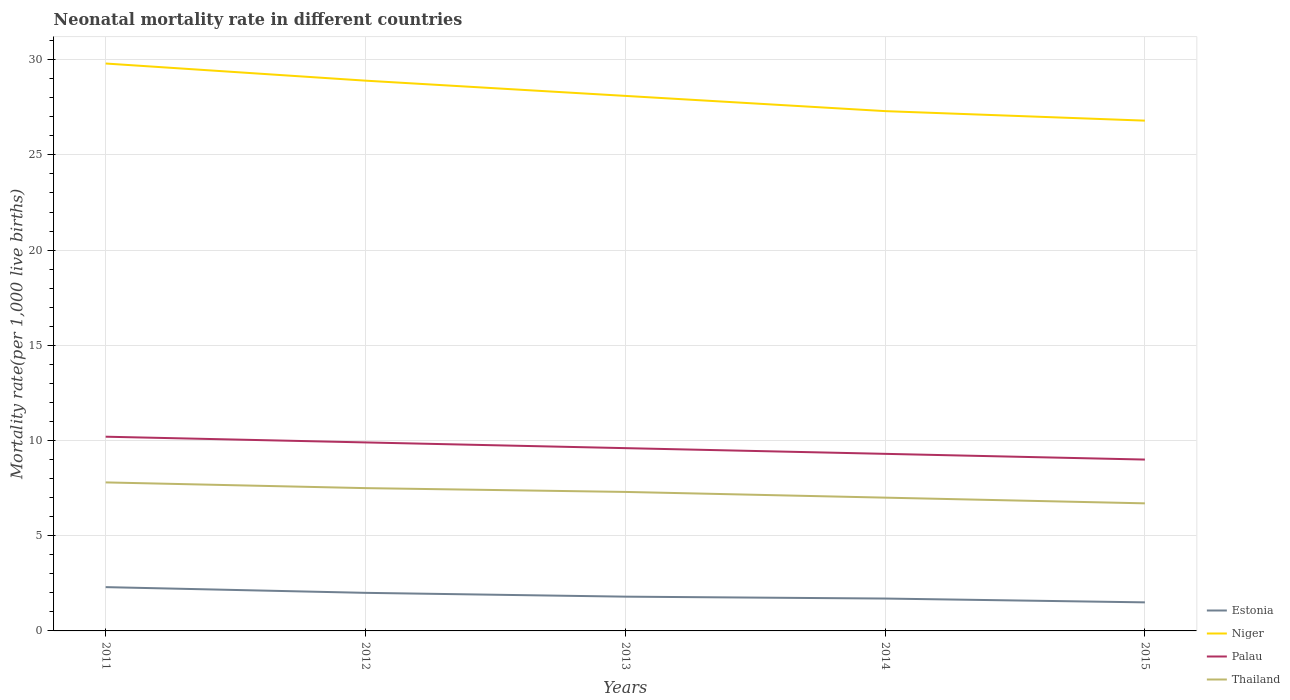How many different coloured lines are there?
Your answer should be compact. 4. Does the line corresponding to Palau intersect with the line corresponding to Niger?
Ensure brevity in your answer.  No. Across all years, what is the maximum neonatal mortality rate in Estonia?
Give a very brief answer. 1.5. In which year was the neonatal mortality rate in Niger maximum?
Offer a very short reply. 2015. What is the total neonatal mortality rate in Thailand in the graph?
Provide a short and direct response. 0.3. What is the difference between the highest and the second highest neonatal mortality rate in Estonia?
Make the answer very short. 0.8. How many years are there in the graph?
Give a very brief answer. 5. Are the values on the major ticks of Y-axis written in scientific E-notation?
Your answer should be compact. No. Does the graph contain any zero values?
Make the answer very short. No. Where does the legend appear in the graph?
Offer a very short reply. Bottom right. How are the legend labels stacked?
Your answer should be compact. Vertical. What is the title of the graph?
Offer a terse response. Neonatal mortality rate in different countries. What is the label or title of the X-axis?
Make the answer very short. Years. What is the label or title of the Y-axis?
Make the answer very short. Mortality rate(per 1,0 live births). What is the Mortality rate(per 1,000 live births) of Estonia in 2011?
Your response must be concise. 2.3. What is the Mortality rate(per 1,000 live births) in Niger in 2011?
Give a very brief answer. 29.8. What is the Mortality rate(per 1,000 live births) of Estonia in 2012?
Keep it short and to the point. 2. What is the Mortality rate(per 1,000 live births) in Niger in 2012?
Provide a short and direct response. 28.9. What is the Mortality rate(per 1,000 live births) of Palau in 2012?
Provide a succinct answer. 9.9. What is the Mortality rate(per 1,000 live births) of Estonia in 2013?
Make the answer very short. 1.8. What is the Mortality rate(per 1,000 live births) of Niger in 2013?
Give a very brief answer. 28.1. What is the Mortality rate(per 1,000 live births) in Palau in 2013?
Offer a very short reply. 9.6. What is the Mortality rate(per 1,000 live births) of Thailand in 2013?
Make the answer very short. 7.3. What is the Mortality rate(per 1,000 live births) of Estonia in 2014?
Offer a very short reply. 1.7. What is the Mortality rate(per 1,000 live births) in Niger in 2014?
Your response must be concise. 27.3. What is the Mortality rate(per 1,000 live births) in Palau in 2014?
Keep it short and to the point. 9.3. What is the Mortality rate(per 1,000 live births) of Thailand in 2014?
Your answer should be very brief. 7. What is the Mortality rate(per 1,000 live births) in Estonia in 2015?
Your answer should be compact. 1.5. What is the Mortality rate(per 1,000 live births) in Niger in 2015?
Provide a short and direct response. 26.8. What is the Mortality rate(per 1,000 live births) in Thailand in 2015?
Keep it short and to the point. 6.7. Across all years, what is the maximum Mortality rate(per 1,000 live births) of Estonia?
Your answer should be compact. 2.3. Across all years, what is the maximum Mortality rate(per 1,000 live births) of Niger?
Your response must be concise. 29.8. Across all years, what is the maximum Mortality rate(per 1,000 live births) in Palau?
Offer a very short reply. 10.2. Across all years, what is the minimum Mortality rate(per 1,000 live births) of Estonia?
Offer a terse response. 1.5. Across all years, what is the minimum Mortality rate(per 1,000 live births) in Niger?
Your answer should be very brief. 26.8. Across all years, what is the minimum Mortality rate(per 1,000 live births) in Palau?
Keep it short and to the point. 9. Across all years, what is the minimum Mortality rate(per 1,000 live births) of Thailand?
Give a very brief answer. 6.7. What is the total Mortality rate(per 1,000 live births) of Estonia in the graph?
Offer a very short reply. 9.3. What is the total Mortality rate(per 1,000 live births) in Niger in the graph?
Give a very brief answer. 140.9. What is the total Mortality rate(per 1,000 live births) in Palau in the graph?
Provide a short and direct response. 48. What is the total Mortality rate(per 1,000 live births) of Thailand in the graph?
Offer a very short reply. 36.3. What is the difference between the Mortality rate(per 1,000 live births) in Palau in 2011 and that in 2012?
Your answer should be very brief. 0.3. What is the difference between the Mortality rate(per 1,000 live births) in Thailand in 2011 and that in 2012?
Your answer should be compact. 0.3. What is the difference between the Mortality rate(per 1,000 live births) of Estonia in 2011 and that in 2013?
Your response must be concise. 0.5. What is the difference between the Mortality rate(per 1,000 live births) of Niger in 2011 and that in 2013?
Offer a very short reply. 1.7. What is the difference between the Mortality rate(per 1,000 live births) in Niger in 2011 and that in 2014?
Make the answer very short. 2.5. What is the difference between the Mortality rate(per 1,000 live births) in Niger in 2011 and that in 2015?
Offer a terse response. 3. What is the difference between the Mortality rate(per 1,000 live births) in Thailand in 2011 and that in 2015?
Make the answer very short. 1.1. What is the difference between the Mortality rate(per 1,000 live births) of Niger in 2012 and that in 2014?
Your answer should be very brief. 1.6. What is the difference between the Mortality rate(per 1,000 live births) of Palau in 2012 and that in 2014?
Give a very brief answer. 0.6. What is the difference between the Mortality rate(per 1,000 live births) in Thailand in 2012 and that in 2015?
Offer a very short reply. 0.8. What is the difference between the Mortality rate(per 1,000 live births) of Estonia in 2013 and that in 2014?
Your response must be concise. 0.1. What is the difference between the Mortality rate(per 1,000 live births) of Thailand in 2013 and that in 2014?
Keep it short and to the point. 0.3. What is the difference between the Mortality rate(per 1,000 live births) in Estonia in 2013 and that in 2015?
Make the answer very short. 0.3. What is the difference between the Mortality rate(per 1,000 live births) of Niger in 2013 and that in 2015?
Offer a terse response. 1.3. What is the difference between the Mortality rate(per 1,000 live births) of Estonia in 2014 and that in 2015?
Offer a terse response. 0.2. What is the difference between the Mortality rate(per 1,000 live births) in Niger in 2014 and that in 2015?
Offer a very short reply. 0.5. What is the difference between the Mortality rate(per 1,000 live births) of Estonia in 2011 and the Mortality rate(per 1,000 live births) of Niger in 2012?
Offer a very short reply. -26.6. What is the difference between the Mortality rate(per 1,000 live births) in Estonia in 2011 and the Mortality rate(per 1,000 live births) in Palau in 2012?
Keep it short and to the point. -7.6. What is the difference between the Mortality rate(per 1,000 live births) in Estonia in 2011 and the Mortality rate(per 1,000 live births) in Thailand in 2012?
Your answer should be very brief. -5.2. What is the difference between the Mortality rate(per 1,000 live births) of Niger in 2011 and the Mortality rate(per 1,000 live births) of Palau in 2012?
Offer a very short reply. 19.9. What is the difference between the Mortality rate(per 1,000 live births) of Niger in 2011 and the Mortality rate(per 1,000 live births) of Thailand in 2012?
Offer a terse response. 22.3. What is the difference between the Mortality rate(per 1,000 live births) of Palau in 2011 and the Mortality rate(per 1,000 live births) of Thailand in 2012?
Your answer should be very brief. 2.7. What is the difference between the Mortality rate(per 1,000 live births) of Estonia in 2011 and the Mortality rate(per 1,000 live births) of Niger in 2013?
Offer a very short reply. -25.8. What is the difference between the Mortality rate(per 1,000 live births) in Estonia in 2011 and the Mortality rate(per 1,000 live births) in Thailand in 2013?
Your answer should be very brief. -5. What is the difference between the Mortality rate(per 1,000 live births) of Niger in 2011 and the Mortality rate(per 1,000 live births) of Palau in 2013?
Give a very brief answer. 20.2. What is the difference between the Mortality rate(per 1,000 live births) of Niger in 2011 and the Mortality rate(per 1,000 live births) of Thailand in 2013?
Give a very brief answer. 22.5. What is the difference between the Mortality rate(per 1,000 live births) in Estonia in 2011 and the Mortality rate(per 1,000 live births) in Palau in 2014?
Your answer should be compact. -7. What is the difference between the Mortality rate(per 1,000 live births) of Estonia in 2011 and the Mortality rate(per 1,000 live births) of Thailand in 2014?
Provide a short and direct response. -4.7. What is the difference between the Mortality rate(per 1,000 live births) in Niger in 2011 and the Mortality rate(per 1,000 live births) in Palau in 2014?
Provide a succinct answer. 20.5. What is the difference between the Mortality rate(per 1,000 live births) in Niger in 2011 and the Mortality rate(per 1,000 live births) in Thailand in 2014?
Make the answer very short. 22.8. What is the difference between the Mortality rate(per 1,000 live births) of Estonia in 2011 and the Mortality rate(per 1,000 live births) of Niger in 2015?
Your answer should be very brief. -24.5. What is the difference between the Mortality rate(per 1,000 live births) of Niger in 2011 and the Mortality rate(per 1,000 live births) of Palau in 2015?
Keep it short and to the point. 20.8. What is the difference between the Mortality rate(per 1,000 live births) of Niger in 2011 and the Mortality rate(per 1,000 live births) of Thailand in 2015?
Your answer should be compact. 23.1. What is the difference between the Mortality rate(per 1,000 live births) of Palau in 2011 and the Mortality rate(per 1,000 live births) of Thailand in 2015?
Offer a very short reply. 3.5. What is the difference between the Mortality rate(per 1,000 live births) of Estonia in 2012 and the Mortality rate(per 1,000 live births) of Niger in 2013?
Your answer should be compact. -26.1. What is the difference between the Mortality rate(per 1,000 live births) in Estonia in 2012 and the Mortality rate(per 1,000 live births) in Palau in 2013?
Offer a terse response. -7.6. What is the difference between the Mortality rate(per 1,000 live births) in Niger in 2012 and the Mortality rate(per 1,000 live births) in Palau in 2013?
Your answer should be very brief. 19.3. What is the difference between the Mortality rate(per 1,000 live births) of Niger in 2012 and the Mortality rate(per 1,000 live births) of Thailand in 2013?
Provide a succinct answer. 21.6. What is the difference between the Mortality rate(per 1,000 live births) in Estonia in 2012 and the Mortality rate(per 1,000 live births) in Niger in 2014?
Your response must be concise. -25.3. What is the difference between the Mortality rate(per 1,000 live births) in Estonia in 2012 and the Mortality rate(per 1,000 live births) in Thailand in 2014?
Give a very brief answer. -5. What is the difference between the Mortality rate(per 1,000 live births) of Niger in 2012 and the Mortality rate(per 1,000 live births) of Palau in 2014?
Ensure brevity in your answer.  19.6. What is the difference between the Mortality rate(per 1,000 live births) of Niger in 2012 and the Mortality rate(per 1,000 live births) of Thailand in 2014?
Ensure brevity in your answer.  21.9. What is the difference between the Mortality rate(per 1,000 live births) of Estonia in 2012 and the Mortality rate(per 1,000 live births) of Niger in 2015?
Provide a short and direct response. -24.8. What is the difference between the Mortality rate(per 1,000 live births) in Estonia in 2012 and the Mortality rate(per 1,000 live births) in Thailand in 2015?
Keep it short and to the point. -4.7. What is the difference between the Mortality rate(per 1,000 live births) of Niger in 2012 and the Mortality rate(per 1,000 live births) of Palau in 2015?
Offer a very short reply. 19.9. What is the difference between the Mortality rate(per 1,000 live births) in Niger in 2012 and the Mortality rate(per 1,000 live births) in Thailand in 2015?
Provide a short and direct response. 22.2. What is the difference between the Mortality rate(per 1,000 live births) of Palau in 2012 and the Mortality rate(per 1,000 live births) of Thailand in 2015?
Provide a short and direct response. 3.2. What is the difference between the Mortality rate(per 1,000 live births) of Estonia in 2013 and the Mortality rate(per 1,000 live births) of Niger in 2014?
Provide a succinct answer. -25.5. What is the difference between the Mortality rate(per 1,000 live births) of Estonia in 2013 and the Mortality rate(per 1,000 live births) of Thailand in 2014?
Your answer should be compact. -5.2. What is the difference between the Mortality rate(per 1,000 live births) in Niger in 2013 and the Mortality rate(per 1,000 live births) in Thailand in 2014?
Your response must be concise. 21.1. What is the difference between the Mortality rate(per 1,000 live births) in Palau in 2013 and the Mortality rate(per 1,000 live births) in Thailand in 2014?
Offer a very short reply. 2.6. What is the difference between the Mortality rate(per 1,000 live births) in Estonia in 2013 and the Mortality rate(per 1,000 live births) in Niger in 2015?
Make the answer very short. -25. What is the difference between the Mortality rate(per 1,000 live births) in Estonia in 2013 and the Mortality rate(per 1,000 live births) in Thailand in 2015?
Your response must be concise. -4.9. What is the difference between the Mortality rate(per 1,000 live births) in Niger in 2013 and the Mortality rate(per 1,000 live births) in Thailand in 2015?
Provide a succinct answer. 21.4. What is the difference between the Mortality rate(per 1,000 live births) in Estonia in 2014 and the Mortality rate(per 1,000 live births) in Niger in 2015?
Your response must be concise. -25.1. What is the difference between the Mortality rate(per 1,000 live births) in Estonia in 2014 and the Mortality rate(per 1,000 live births) in Palau in 2015?
Your answer should be very brief. -7.3. What is the difference between the Mortality rate(per 1,000 live births) in Estonia in 2014 and the Mortality rate(per 1,000 live births) in Thailand in 2015?
Your response must be concise. -5. What is the difference between the Mortality rate(per 1,000 live births) in Niger in 2014 and the Mortality rate(per 1,000 live births) in Palau in 2015?
Offer a very short reply. 18.3. What is the difference between the Mortality rate(per 1,000 live births) in Niger in 2014 and the Mortality rate(per 1,000 live births) in Thailand in 2015?
Your answer should be compact. 20.6. What is the average Mortality rate(per 1,000 live births) in Estonia per year?
Your answer should be very brief. 1.86. What is the average Mortality rate(per 1,000 live births) in Niger per year?
Your response must be concise. 28.18. What is the average Mortality rate(per 1,000 live births) of Thailand per year?
Your response must be concise. 7.26. In the year 2011, what is the difference between the Mortality rate(per 1,000 live births) of Estonia and Mortality rate(per 1,000 live births) of Niger?
Your response must be concise. -27.5. In the year 2011, what is the difference between the Mortality rate(per 1,000 live births) in Niger and Mortality rate(per 1,000 live births) in Palau?
Your response must be concise. 19.6. In the year 2011, what is the difference between the Mortality rate(per 1,000 live births) in Niger and Mortality rate(per 1,000 live births) in Thailand?
Your answer should be very brief. 22. In the year 2011, what is the difference between the Mortality rate(per 1,000 live births) in Palau and Mortality rate(per 1,000 live births) in Thailand?
Give a very brief answer. 2.4. In the year 2012, what is the difference between the Mortality rate(per 1,000 live births) of Estonia and Mortality rate(per 1,000 live births) of Niger?
Provide a succinct answer. -26.9. In the year 2012, what is the difference between the Mortality rate(per 1,000 live births) in Estonia and Mortality rate(per 1,000 live births) in Palau?
Give a very brief answer. -7.9. In the year 2012, what is the difference between the Mortality rate(per 1,000 live births) in Estonia and Mortality rate(per 1,000 live births) in Thailand?
Offer a very short reply. -5.5. In the year 2012, what is the difference between the Mortality rate(per 1,000 live births) in Niger and Mortality rate(per 1,000 live births) in Thailand?
Provide a short and direct response. 21.4. In the year 2013, what is the difference between the Mortality rate(per 1,000 live births) of Estonia and Mortality rate(per 1,000 live births) of Niger?
Make the answer very short. -26.3. In the year 2013, what is the difference between the Mortality rate(per 1,000 live births) in Niger and Mortality rate(per 1,000 live births) in Thailand?
Provide a succinct answer. 20.8. In the year 2013, what is the difference between the Mortality rate(per 1,000 live births) of Palau and Mortality rate(per 1,000 live births) of Thailand?
Offer a terse response. 2.3. In the year 2014, what is the difference between the Mortality rate(per 1,000 live births) of Estonia and Mortality rate(per 1,000 live births) of Niger?
Offer a very short reply. -25.6. In the year 2014, what is the difference between the Mortality rate(per 1,000 live births) of Estonia and Mortality rate(per 1,000 live births) of Thailand?
Offer a very short reply. -5.3. In the year 2014, what is the difference between the Mortality rate(per 1,000 live births) in Niger and Mortality rate(per 1,000 live births) in Palau?
Ensure brevity in your answer.  18. In the year 2014, what is the difference between the Mortality rate(per 1,000 live births) in Niger and Mortality rate(per 1,000 live births) in Thailand?
Offer a very short reply. 20.3. In the year 2014, what is the difference between the Mortality rate(per 1,000 live births) of Palau and Mortality rate(per 1,000 live births) of Thailand?
Make the answer very short. 2.3. In the year 2015, what is the difference between the Mortality rate(per 1,000 live births) in Estonia and Mortality rate(per 1,000 live births) in Niger?
Give a very brief answer. -25.3. In the year 2015, what is the difference between the Mortality rate(per 1,000 live births) of Estonia and Mortality rate(per 1,000 live births) of Thailand?
Provide a succinct answer. -5.2. In the year 2015, what is the difference between the Mortality rate(per 1,000 live births) in Niger and Mortality rate(per 1,000 live births) in Thailand?
Provide a short and direct response. 20.1. In the year 2015, what is the difference between the Mortality rate(per 1,000 live births) of Palau and Mortality rate(per 1,000 live births) of Thailand?
Ensure brevity in your answer.  2.3. What is the ratio of the Mortality rate(per 1,000 live births) of Estonia in 2011 to that in 2012?
Your response must be concise. 1.15. What is the ratio of the Mortality rate(per 1,000 live births) in Niger in 2011 to that in 2012?
Provide a short and direct response. 1.03. What is the ratio of the Mortality rate(per 1,000 live births) in Palau in 2011 to that in 2012?
Your answer should be compact. 1.03. What is the ratio of the Mortality rate(per 1,000 live births) in Estonia in 2011 to that in 2013?
Make the answer very short. 1.28. What is the ratio of the Mortality rate(per 1,000 live births) of Niger in 2011 to that in 2013?
Offer a very short reply. 1.06. What is the ratio of the Mortality rate(per 1,000 live births) of Thailand in 2011 to that in 2013?
Keep it short and to the point. 1.07. What is the ratio of the Mortality rate(per 1,000 live births) in Estonia in 2011 to that in 2014?
Your answer should be compact. 1.35. What is the ratio of the Mortality rate(per 1,000 live births) in Niger in 2011 to that in 2014?
Make the answer very short. 1.09. What is the ratio of the Mortality rate(per 1,000 live births) in Palau in 2011 to that in 2014?
Give a very brief answer. 1.1. What is the ratio of the Mortality rate(per 1,000 live births) in Thailand in 2011 to that in 2014?
Your response must be concise. 1.11. What is the ratio of the Mortality rate(per 1,000 live births) of Estonia in 2011 to that in 2015?
Provide a succinct answer. 1.53. What is the ratio of the Mortality rate(per 1,000 live births) of Niger in 2011 to that in 2015?
Provide a short and direct response. 1.11. What is the ratio of the Mortality rate(per 1,000 live births) of Palau in 2011 to that in 2015?
Keep it short and to the point. 1.13. What is the ratio of the Mortality rate(per 1,000 live births) of Thailand in 2011 to that in 2015?
Provide a short and direct response. 1.16. What is the ratio of the Mortality rate(per 1,000 live births) of Estonia in 2012 to that in 2013?
Provide a succinct answer. 1.11. What is the ratio of the Mortality rate(per 1,000 live births) in Niger in 2012 to that in 2013?
Provide a short and direct response. 1.03. What is the ratio of the Mortality rate(per 1,000 live births) in Palau in 2012 to that in 2013?
Keep it short and to the point. 1.03. What is the ratio of the Mortality rate(per 1,000 live births) in Thailand in 2012 to that in 2013?
Offer a terse response. 1.03. What is the ratio of the Mortality rate(per 1,000 live births) of Estonia in 2012 to that in 2014?
Your response must be concise. 1.18. What is the ratio of the Mortality rate(per 1,000 live births) of Niger in 2012 to that in 2014?
Provide a short and direct response. 1.06. What is the ratio of the Mortality rate(per 1,000 live births) in Palau in 2012 to that in 2014?
Ensure brevity in your answer.  1.06. What is the ratio of the Mortality rate(per 1,000 live births) of Thailand in 2012 to that in 2014?
Make the answer very short. 1.07. What is the ratio of the Mortality rate(per 1,000 live births) of Estonia in 2012 to that in 2015?
Offer a terse response. 1.33. What is the ratio of the Mortality rate(per 1,000 live births) in Niger in 2012 to that in 2015?
Provide a succinct answer. 1.08. What is the ratio of the Mortality rate(per 1,000 live births) in Palau in 2012 to that in 2015?
Make the answer very short. 1.1. What is the ratio of the Mortality rate(per 1,000 live births) of Thailand in 2012 to that in 2015?
Offer a very short reply. 1.12. What is the ratio of the Mortality rate(per 1,000 live births) in Estonia in 2013 to that in 2014?
Provide a succinct answer. 1.06. What is the ratio of the Mortality rate(per 1,000 live births) in Niger in 2013 to that in 2014?
Keep it short and to the point. 1.03. What is the ratio of the Mortality rate(per 1,000 live births) of Palau in 2013 to that in 2014?
Ensure brevity in your answer.  1.03. What is the ratio of the Mortality rate(per 1,000 live births) of Thailand in 2013 to that in 2014?
Offer a very short reply. 1.04. What is the ratio of the Mortality rate(per 1,000 live births) in Estonia in 2013 to that in 2015?
Ensure brevity in your answer.  1.2. What is the ratio of the Mortality rate(per 1,000 live births) in Niger in 2013 to that in 2015?
Your answer should be very brief. 1.05. What is the ratio of the Mortality rate(per 1,000 live births) of Palau in 2013 to that in 2015?
Provide a succinct answer. 1.07. What is the ratio of the Mortality rate(per 1,000 live births) in Thailand in 2013 to that in 2015?
Provide a succinct answer. 1.09. What is the ratio of the Mortality rate(per 1,000 live births) of Estonia in 2014 to that in 2015?
Offer a very short reply. 1.13. What is the ratio of the Mortality rate(per 1,000 live births) of Niger in 2014 to that in 2015?
Provide a short and direct response. 1.02. What is the ratio of the Mortality rate(per 1,000 live births) of Thailand in 2014 to that in 2015?
Your response must be concise. 1.04. What is the difference between the highest and the second highest Mortality rate(per 1,000 live births) of Estonia?
Provide a short and direct response. 0.3. What is the difference between the highest and the second highest Mortality rate(per 1,000 live births) of Palau?
Your response must be concise. 0.3. What is the difference between the highest and the second highest Mortality rate(per 1,000 live births) of Thailand?
Keep it short and to the point. 0.3. What is the difference between the highest and the lowest Mortality rate(per 1,000 live births) of Thailand?
Keep it short and to the point. 1.1. 